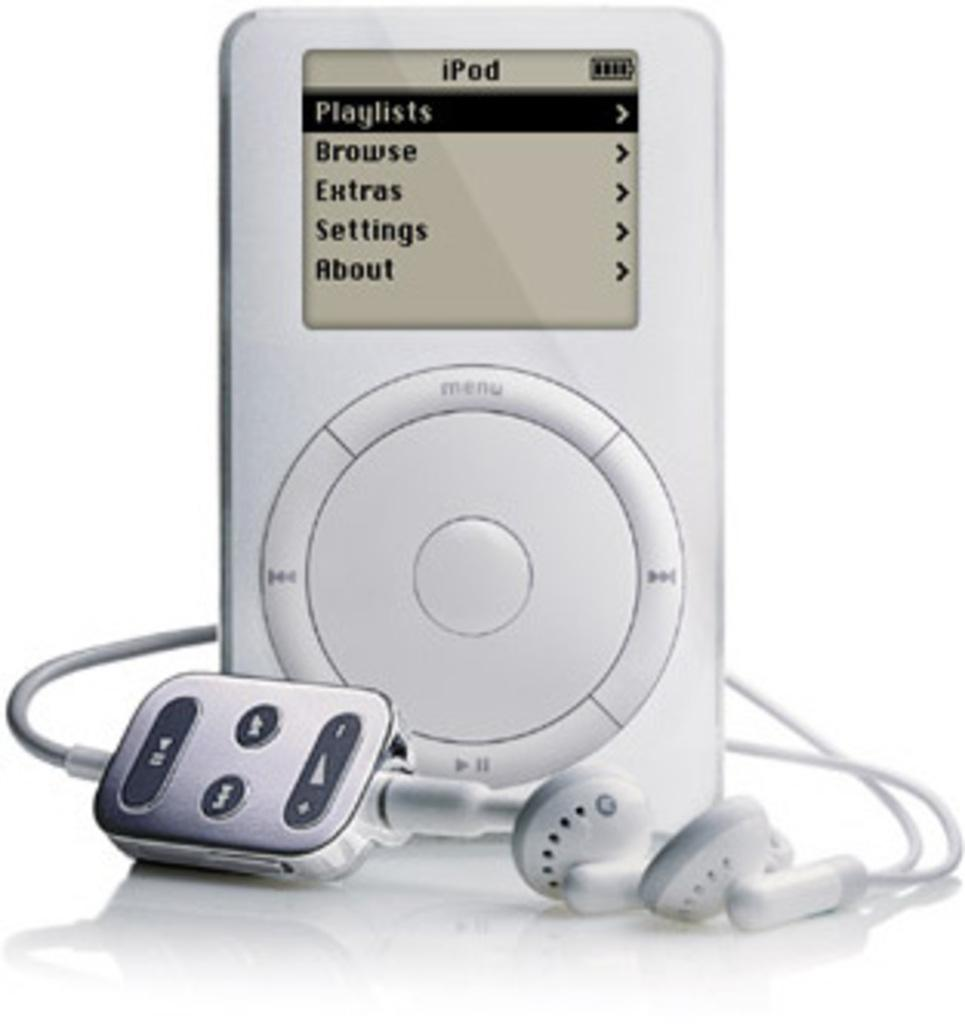What electronic device is present in the image? There is an iPod in the image. What accessory is used with the iPod in the image? Earphones are visible in the image. What can be seen on the iPod screen? There is text on the iPod screen. What scent is associated with the iPod in the image? There is no mention of a scent in the image, as it features an iPod and earphones. 